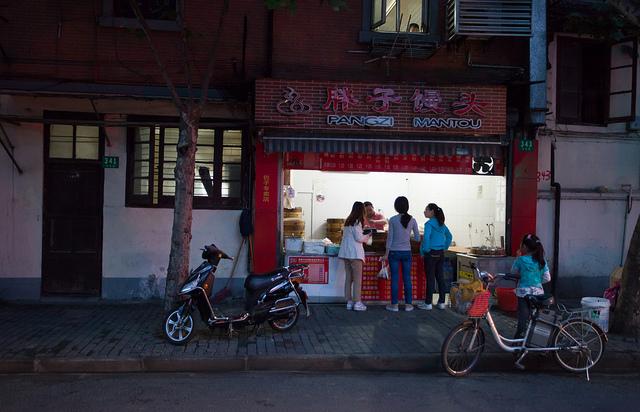What is next to the people?
Give a very brief answer. Bikes. Is this a mechanic shop?
Answer briefly. No. How many bikes?
Answer briefly. 2. How many people are here?
Give a very brief answer. 5. Is this bike being repaired?
Concise answer only. No. Are the bikes secure?
Keep it brief. No. Are there people sitting on a bench?
Write a very short answer. No. What is sitting in the window?
Answer briefly. Food. Is this probably an Asian city?
Quick response, please. Yes. Is the bike tied to a pole?
Write a very short answer. No. How many wheels?
Write a very short answer. 4. Is this display inside or outside?
Short answer required. Outside. What is the bike tied to?
Give a very brief answer. Tree. What is the sidewalk made of?
Write a very short answer. Bricks. Is there any color in the picture?
Be succinct. Yes. What is on the bike?
Keep it brief. Nothing. Are the bikes chained up?
Give a very brief answer. No. 